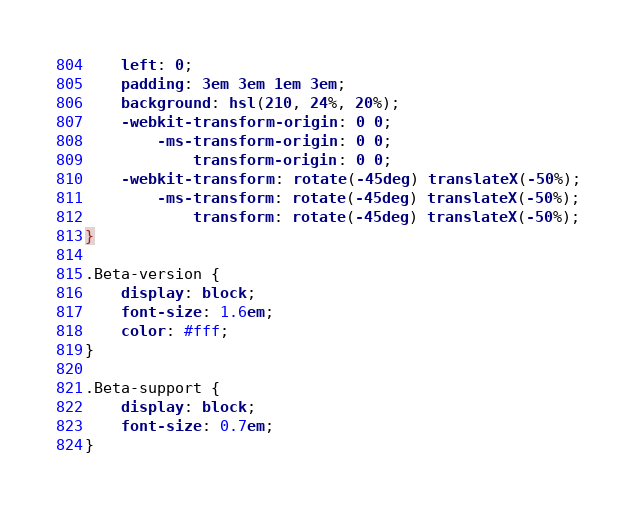<code> <loc_0><loc_0><loc_500><loc_500><_CSS_>    left: 0;
    padding: 3em 3em 1em 3em;
    background: hsl(210, 24%, 20%);
    -webkit-transform-origin: 0 0;
        -ms-transform-origin: 0 0;
            transform-origin: 0 0;
    -webkit-transform: rotate(-45deg) translateX(-50%);
        -ms-transform: rotate(-45deg) translateX(-50%);
            transform: rotate(-45deg) translateX(-50%);
}

.Beta-version {
    display: block;
    font-size: 1.6em;
    color: #fff;
}

.Beta-support {
    display: block;
    font-size: 0.7em;
}
</code> 